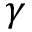Convert formula to latex. <formula><loc_0><loc_0><loc_500><loc_500>\gamma</formula> 